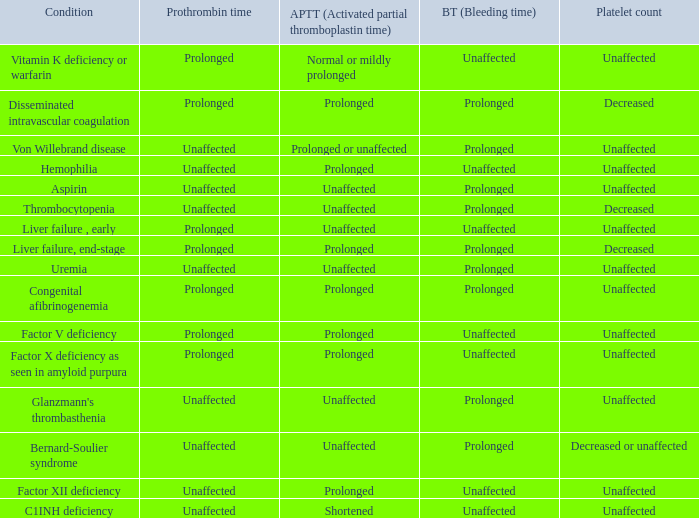Which Condition has an unaffected Partial thromboplastin time, Platelet count, and a Prothrombin time? Aspirin, Uremia, Glanzmann's thrombasthenia. 